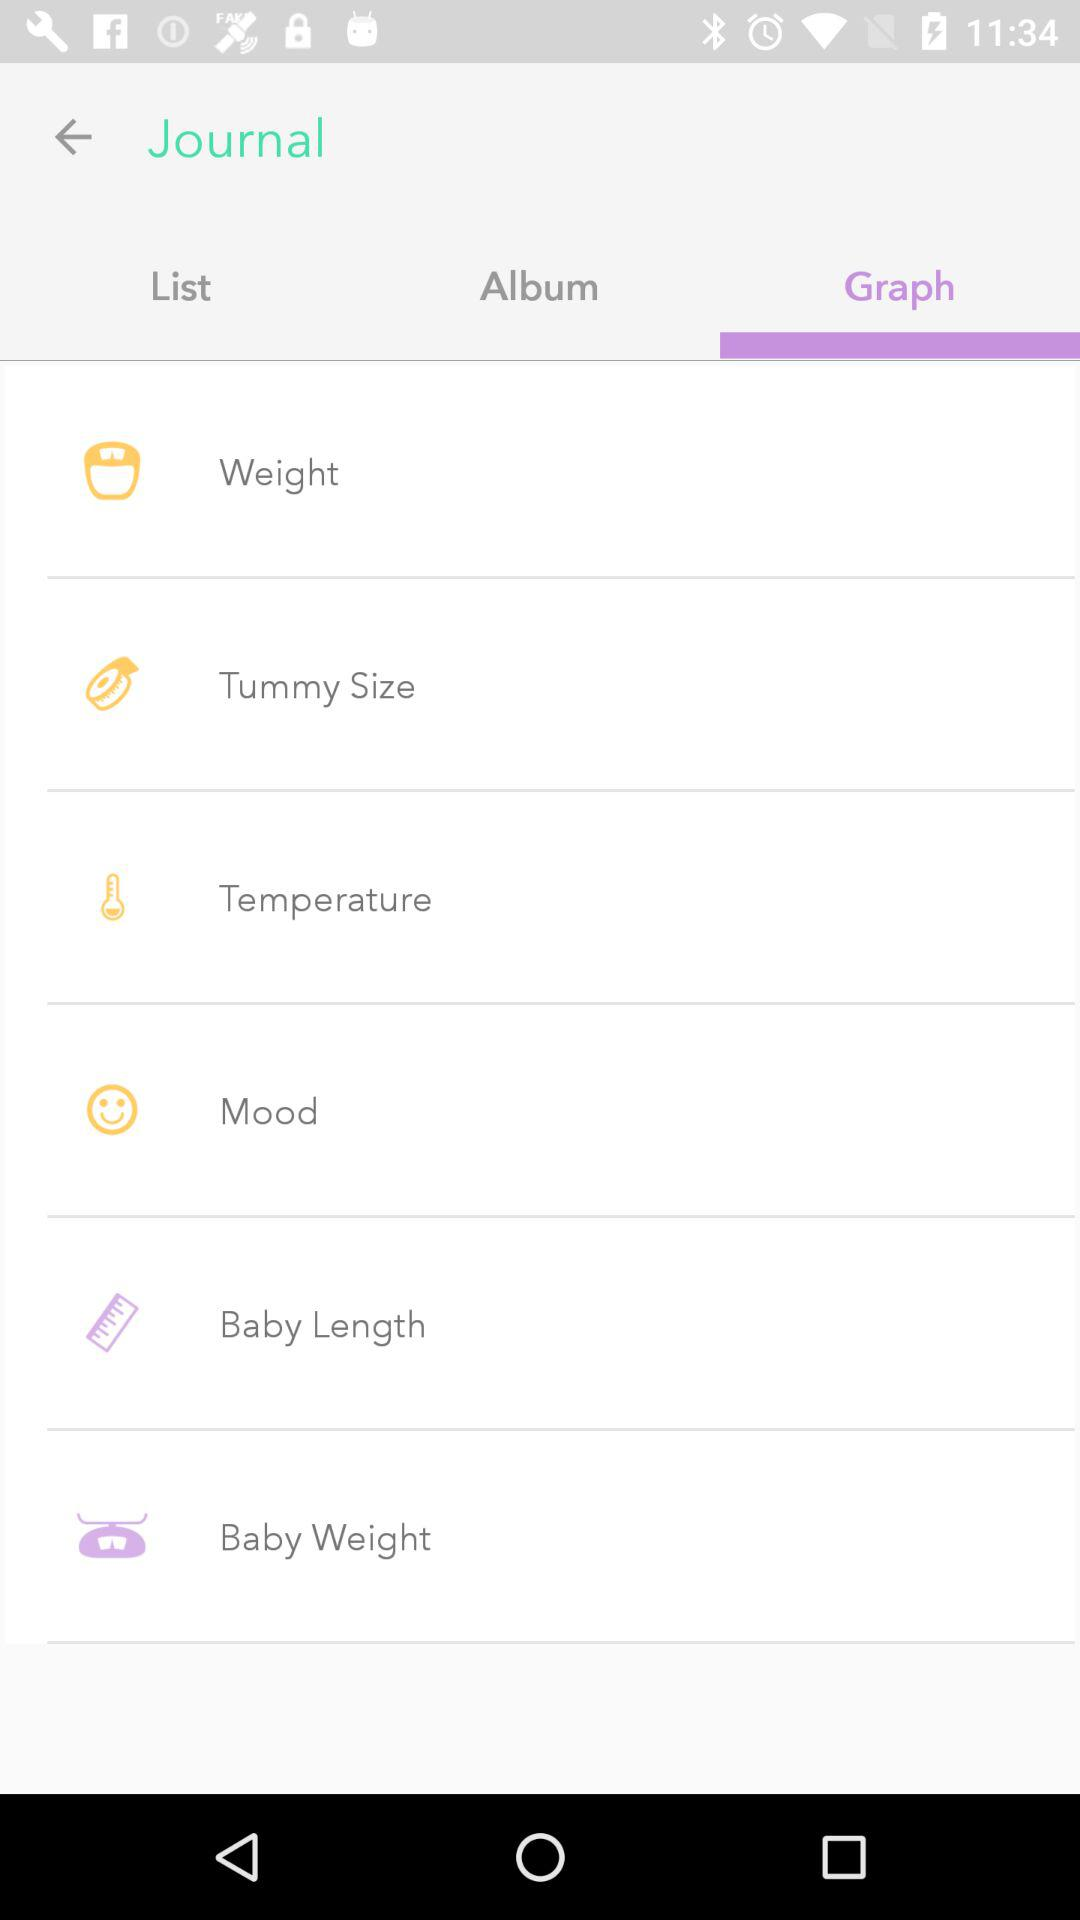Which tab is selected? The selected tab is "Graph". 